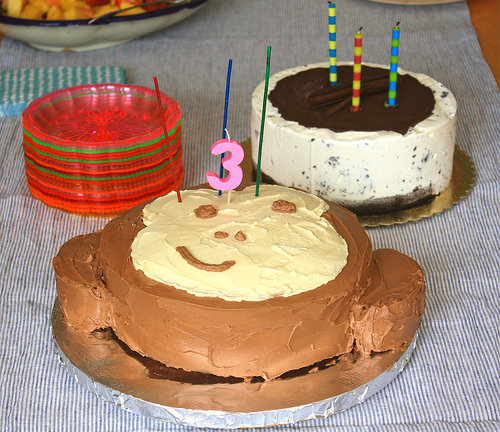<image>
Can you confirm if the cloth is on the table? Yes. Looking at the image, I can see the cloth is positioned on top of the table, with the table providing support. Is the candle on the cake? No. The candle is not positioned on the cake. They may be near each other, but the candle is not supported by or resting on top of the cake. 